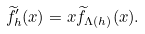Convert formula to latex. <formula><loc_0><loc_0><loc_500><loc_500>\widetilde { f } _ { h } ^ { \prime } ( x ) = x \widetilde { f } _ { \Lambda ( h ) } ( x ) .</formula> 